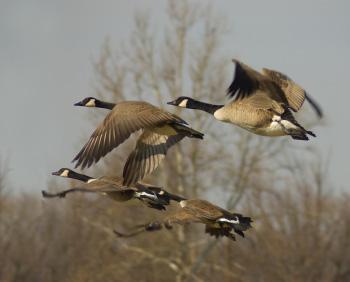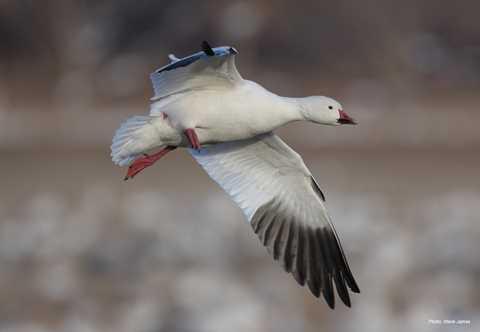The first image is the image on the left, the second image is the image on the right. Evaluate the accuracy of this statement regarding the images: "One image shows at least four black-necked geese flying leftward, and the other image shows no more than two geese flying and they do not have black necks.". Is it true? Answer yes or no. Yes. The first image is the image on the left, the second image is the image on the right. Assess this claim about the two images: "There is no more than two ducks in the left image.". Correct or not? Answer yes or no. No. 